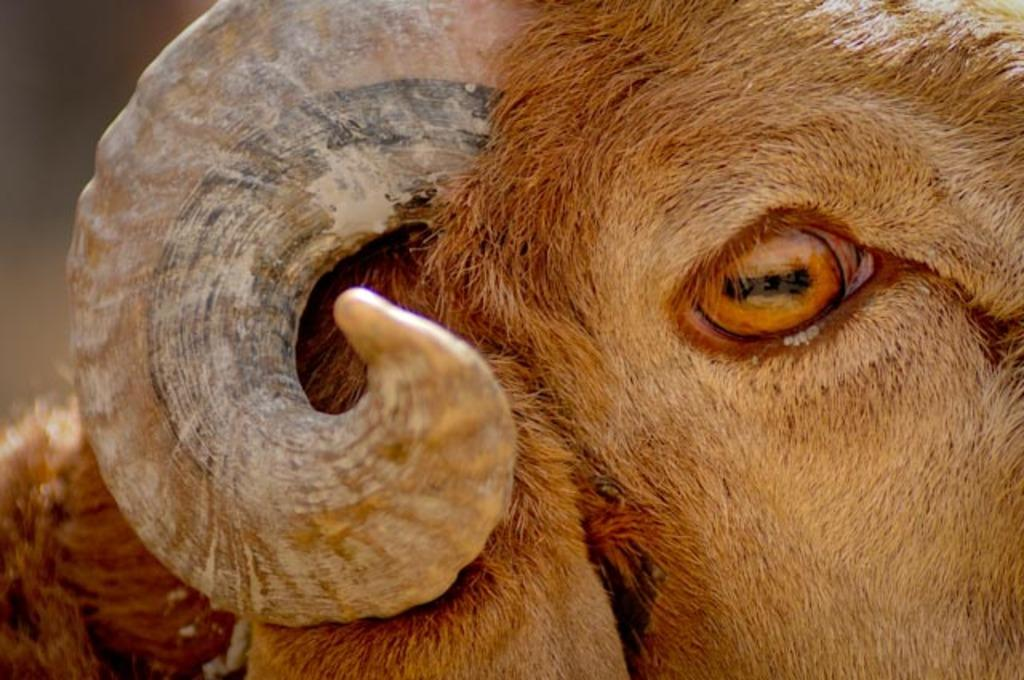What object can be seen in the image that is typically used for making noise? There is a horn in the image. What part of an animal is depicted in the image? There is an eye of a sheep in the image. Can you tell me what the sheep is saying after it talks in the image? Sheep do not talk, so there is no afterthought to consider. What type of cream is being used to decorate the horn in the image? There is no cream present in the image, and the horn is not being decorated. 